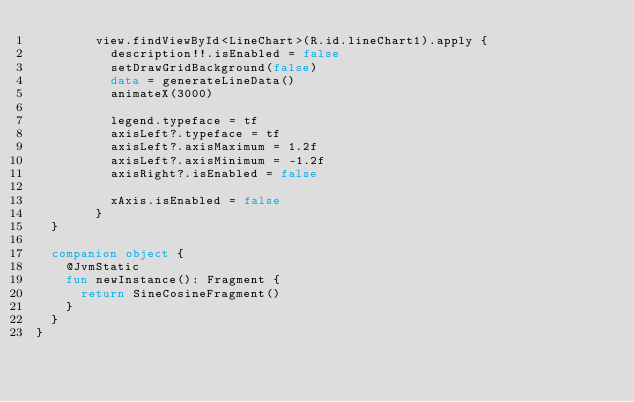Convert code to text. <code><loc_0><loc_0><loc_500><loc_500><_Kotlin_>        view.findViewById<LineChart>(R.id.lineChart1).apply {
          description!!.isEnabled = false
          setDrawGridBackground(false)
          data = generateLineData()
          animateX(3000)

          legend.typeface = tf
          axisLeft?.typeface = tf
          axisLeft?.axisMaximum = 1.2f
          axisLeft?.axisMinimum = -1.2f
          axisRight?.isEnabled = false

          xAxis.isEnabled = false
        }
  }

  companion object {
    @JvmStatic
    fun newInstance(): Fragment {
      return SineCosineFragment()
    }
  }
}
</code> 